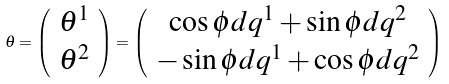<formula> <loc_0><loc_0><loc_500><loc_500>\theta = \left ( \begin{array} { c } \theta ^ { 1 } \\ \theta ^ { 2 } \end{array} \right ) = \left ( \begin{array} { c } \cos \phi d q ^ { 1 } + \sin \phi d q ^ { 2 } \\ - \sin \phi d q ^ { 1 } + \cos \phi d q ^ { 2 } \end{array} \right )</formula> 